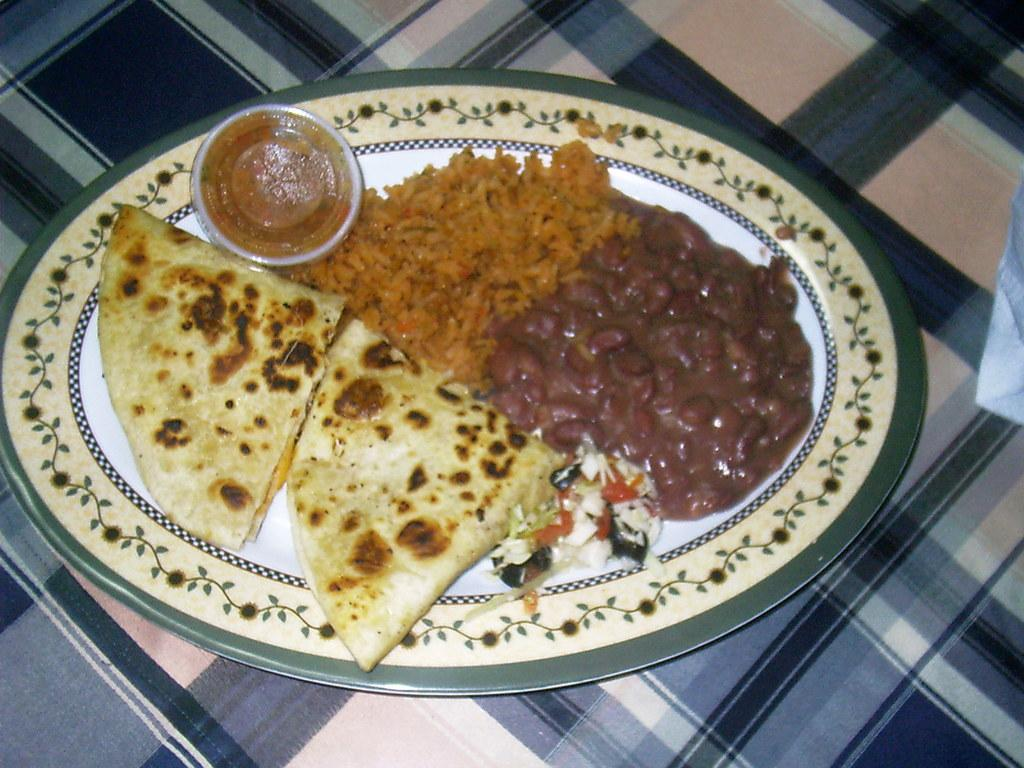What types of food items can be seen in the image? There are food items in the image, but their specific types cannot be determined from the provided facts. What is the small container on the plate? There is a tiny plastic box with a lid on the plate. What is the plate resting on? The plate is on a cloth. What date is circled on the calendar in the image? There is no calendar present in the image, so it is not possible to answer that question. 